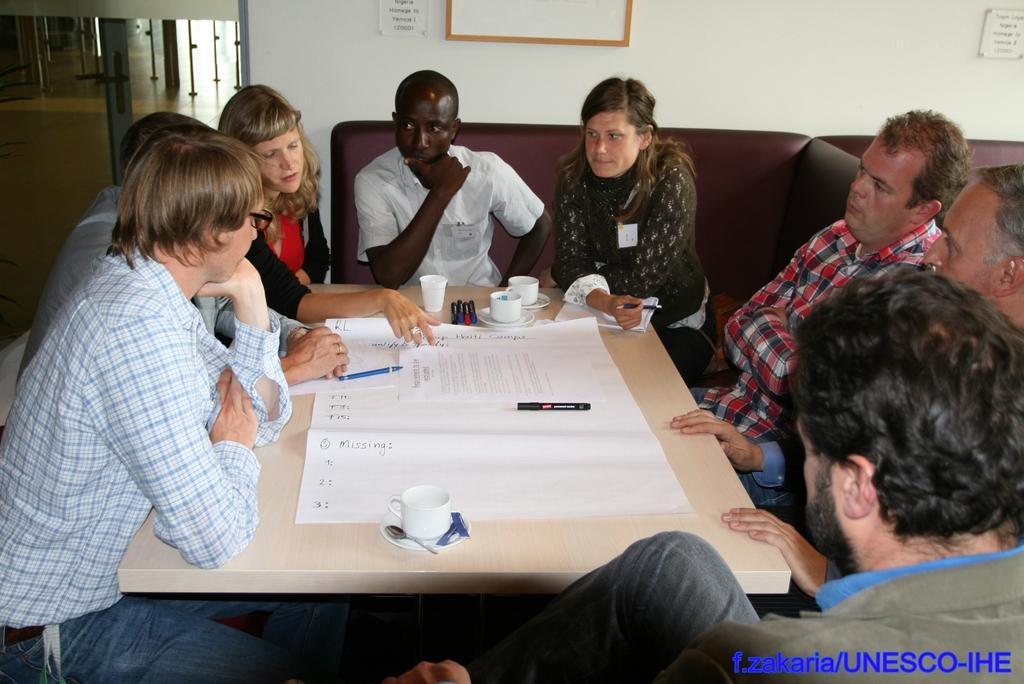In one or two sentences, can you explain what this image depicts? There is a room. There is a group of people. They are sitting on a chairs. There is a table. There is a paper,pen,cup,saucer on a table. We can see in background window and white color wall. 